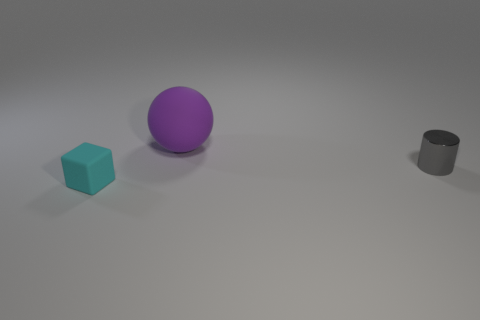What colors are the objects in the image? The image features three objects, each with its own distinct color. The cube is blue, the sphere is purple, and the cylinder is gray. 